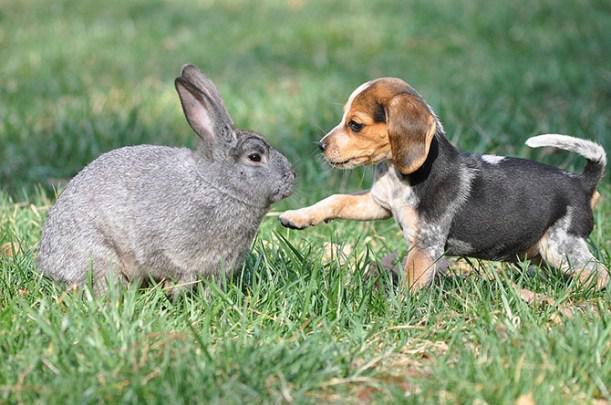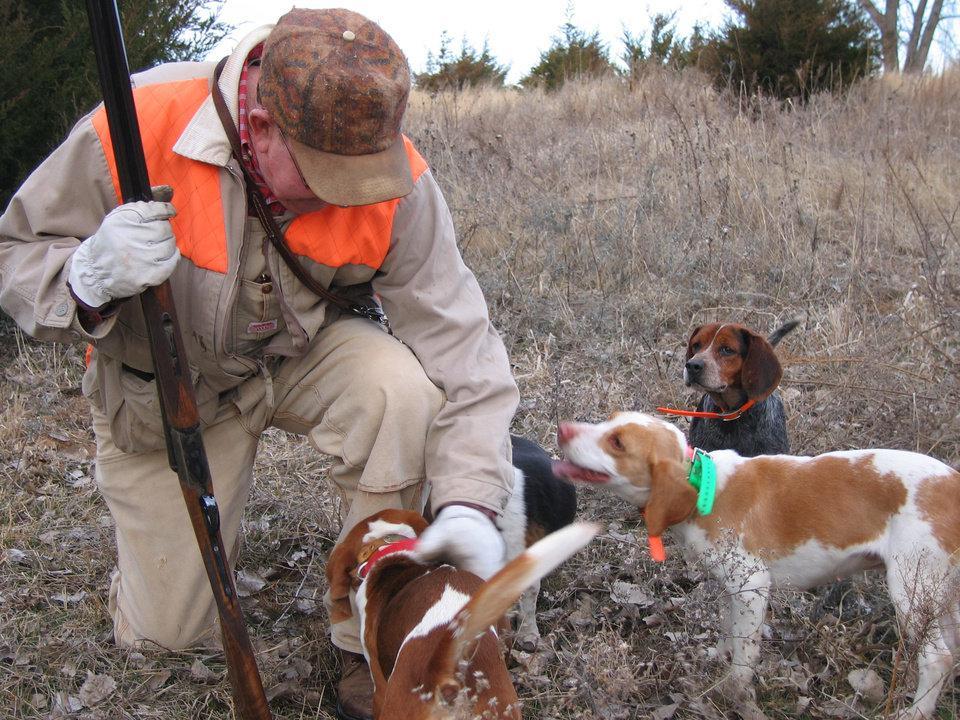The first image is the image on the left, the second image is the image on the right. Considering the images on both sides, is "There are exactly two animals in the image on the left." valid? Answer yes or no. Yes. 